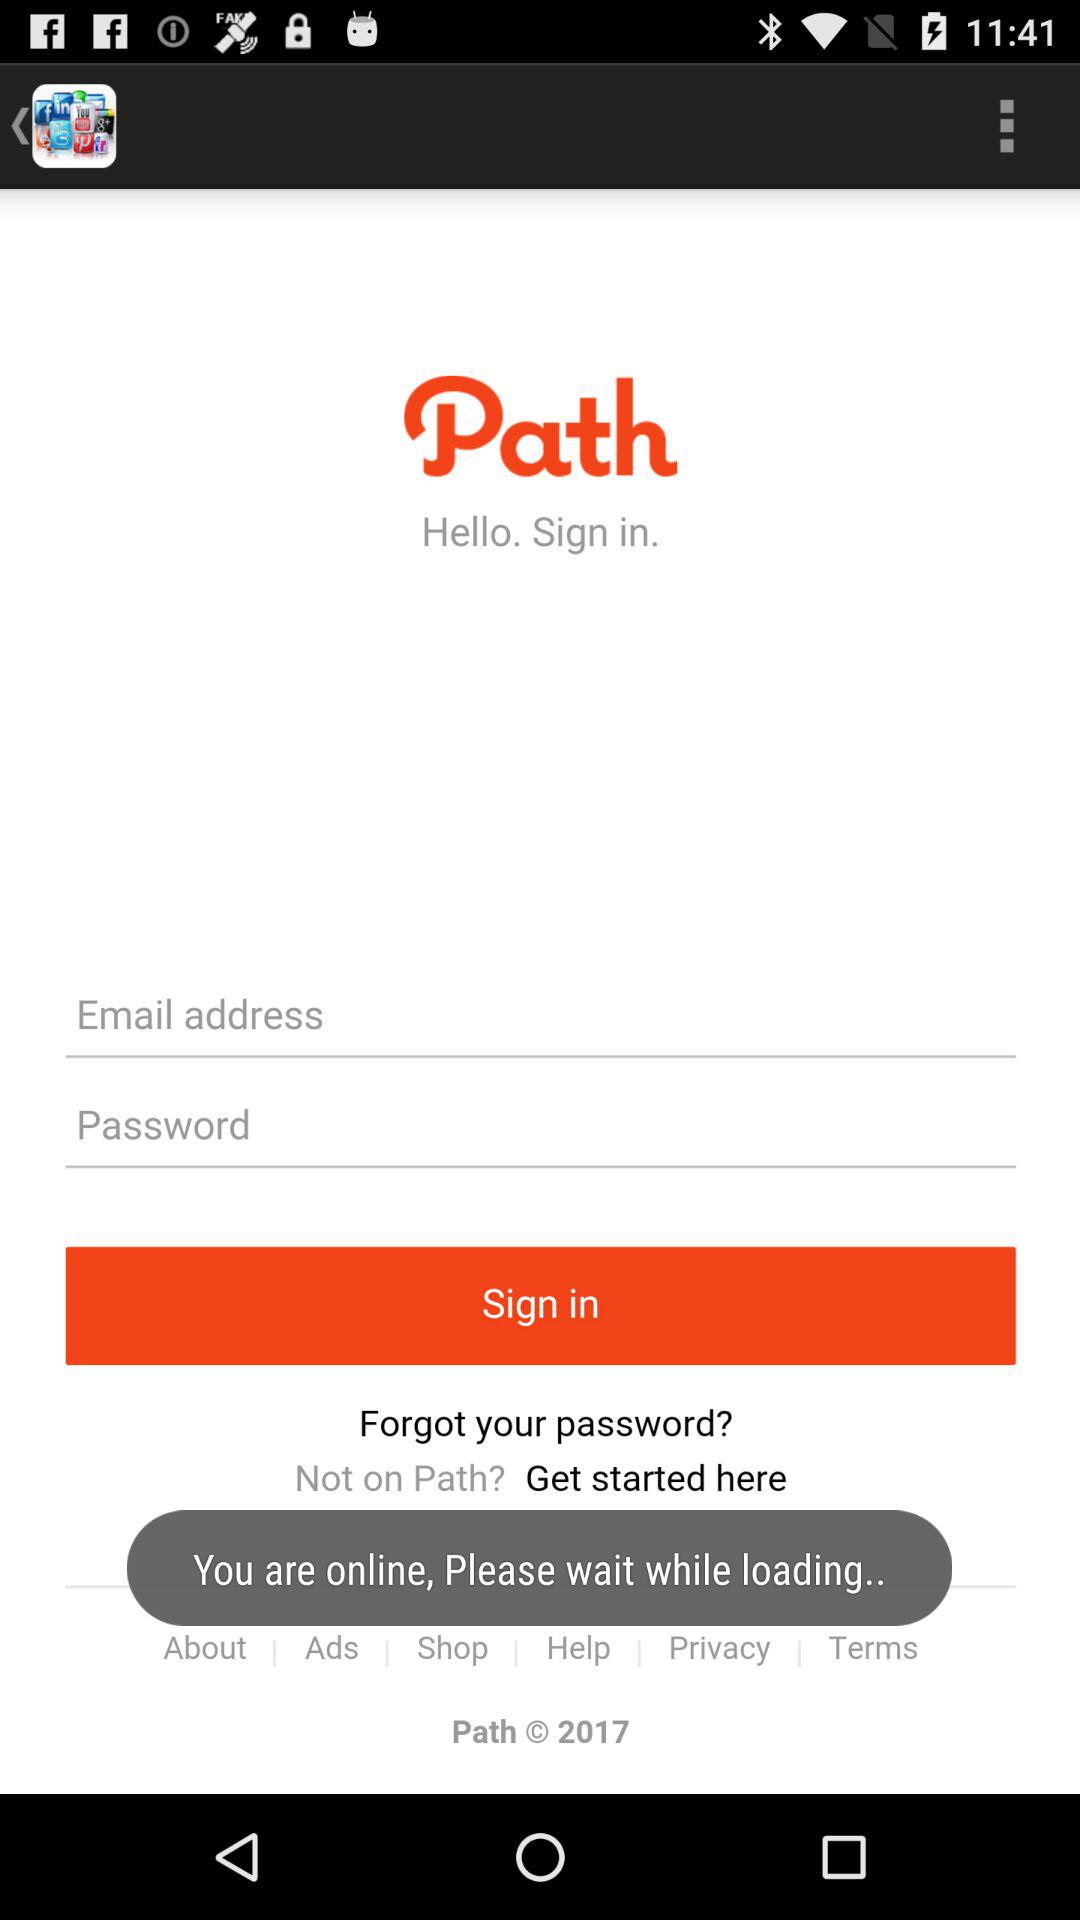What is the name of the application? The name of the application is "Path". 